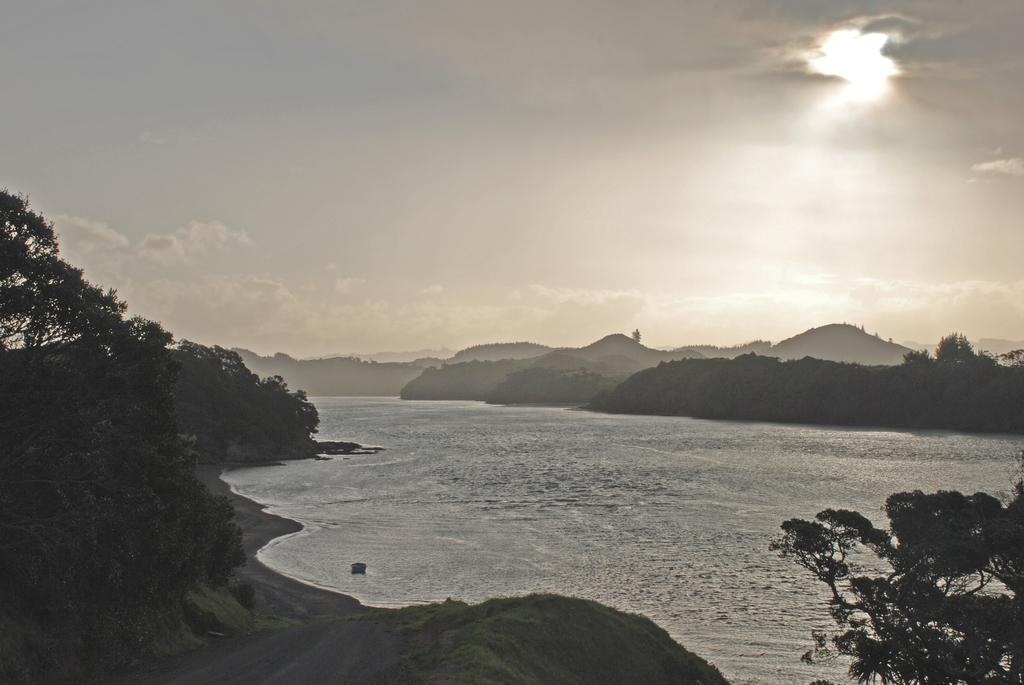Where was the picture taken? The picture was clicked outside the city. What is the main subject in the center of the image? There is a water body in the center of the image. What type of vegetation can be seen on the left side of the image? There are trees and plants on the left side of the image. What can be seen in the background of the image? There is a sky and hills visible in the background of the image. How much salt is present in the water body in the image? There is no information about the salt content in the water body in the image. What type of dust can be seen blowing in the image? There is no dust visible in the image; it features a water body, trees and plants, and a sky with hills in the background. 